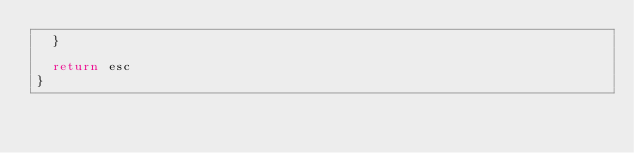Convert code to text. <code><loc_0><loc_0><loc_500><loc_500><_JavaScript_>  }

  return esc
}
</code> 